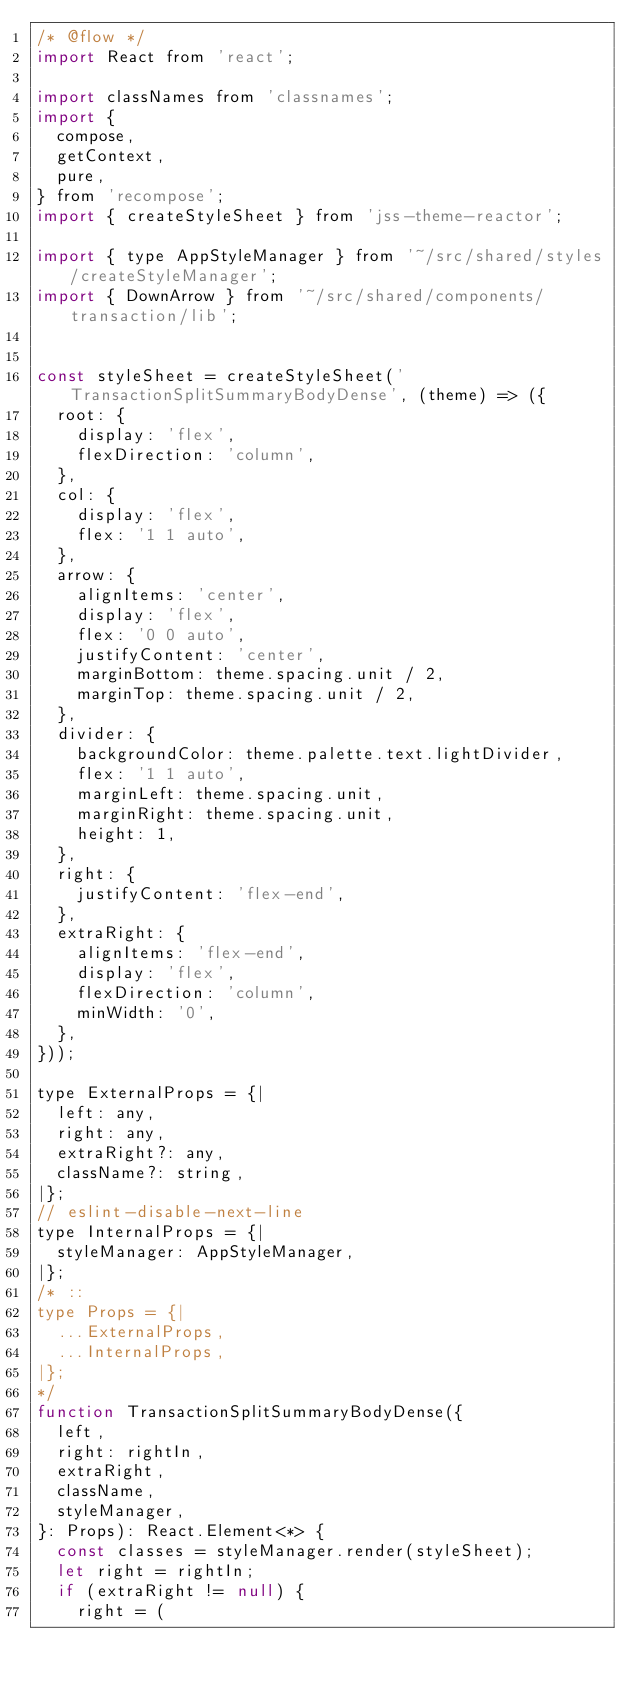<code> <loc_0><loc_0><loc_500><loc_500><_JavaScript_>/* @flow */
import React from 'react';

import classNames from 'classnames';
import {
  compose,
  getContext,
  pure,
} from 'recompose';
import { createStyleSheet } from 'jss-theme-reactor';

import { type AppStyleManager } from '~/src/shared/styles/createStyleManager';
import { DownArrow } from '~/src/shared/components/transaction/lib';


const styleSheet = createStyleSheet('TransactionSplitSummaryBodyDense', (theme) => ({
  root: {
    display: 'flex',
    flexDirection: 'column',
  },
  col: {
    display: 'flex',
    flex: '1 1 auto',
  },
  arrow: {
    alignItems: 'center',
    display: 'flex',
    flex: '0 0 auto',
    justifyContent: 'center',
    marginBottom: theme.spacing.unit / 2,
    marginTop: theme.spacing.unit / 2,
  },
  divider: {
    backgroundColor: theme.palette.text.lightDivider,
    flex: '1 1 auto',
    marginLeft: theme.spacing.unit,
    marginRight: theme.spacing.unit,
    height: 1,
  },
  right: {
    justifyContent: 'flex-end',
  },
  extraRight: {
    alignItems: 'flex-end',
    display: 'flex',
    flexDirection: 'column',
    minWidth: '0',
  },
}));

type ExternalProps = {|
  left: any,
  right: any,
  extraRight?: any,
  className?: string,
|};
// eslint-disable-next-line
type InternalProps = {|
  styleManager: AppStyleManager,
|};
/* ::
type Props = {|
  ...ExternalProps,
  ...InternalProps,
|};
*/
function TransactionSplitSummaryBodyDense({
  left,
  right: rightIn,
  extraRight,
  className,
  styleManager,
}: Props): React.Element<*> {
  const classes = styleManager.render(styleSheet);
  let right = rightIn;
  if (extraRight != null) {
    right = (</code> 